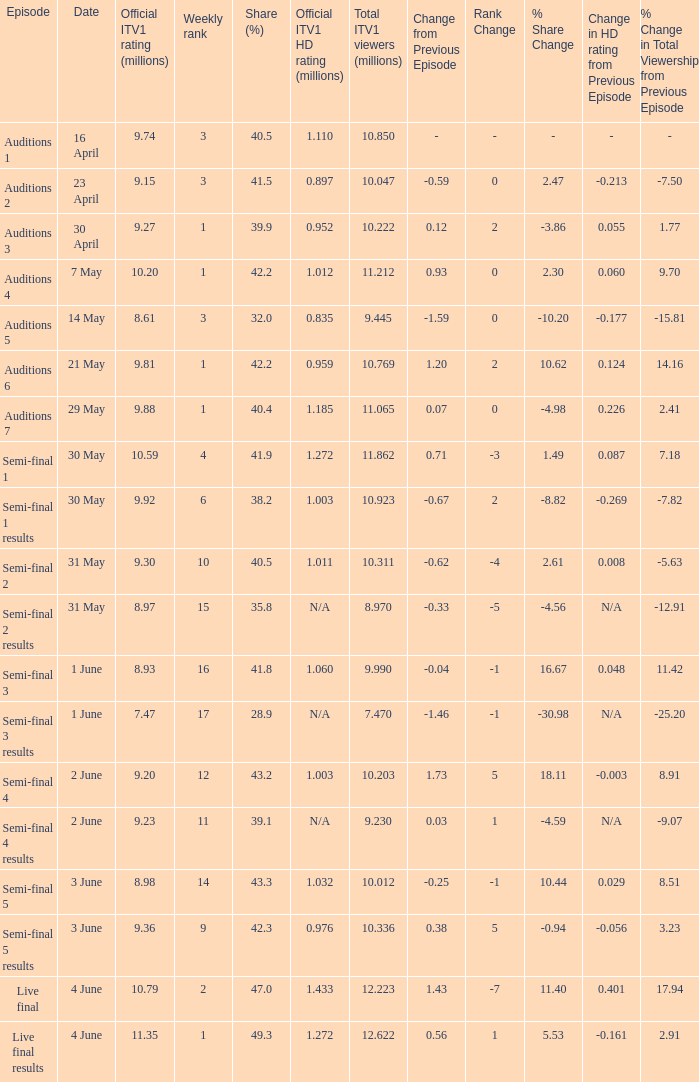What was the share (%) for the Semi-Final 2 episode?  40.5. 